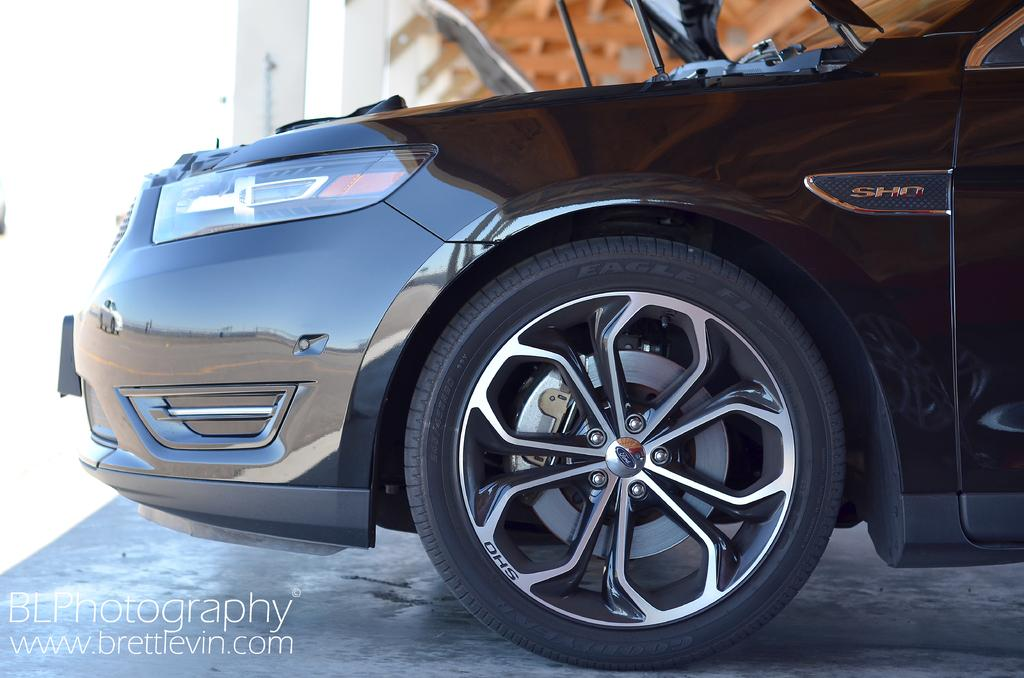What is the main subject of the image? The main subject of the image is a car. Can you describe any additional details about the car? Unfortunately, the provided facts do not include any additional details about the car. What is located in the left bottom corner of the image? There is text or an image in the left bottom corner of the image. What type of skirt is visible in the image? There is no skirt present in the image. 